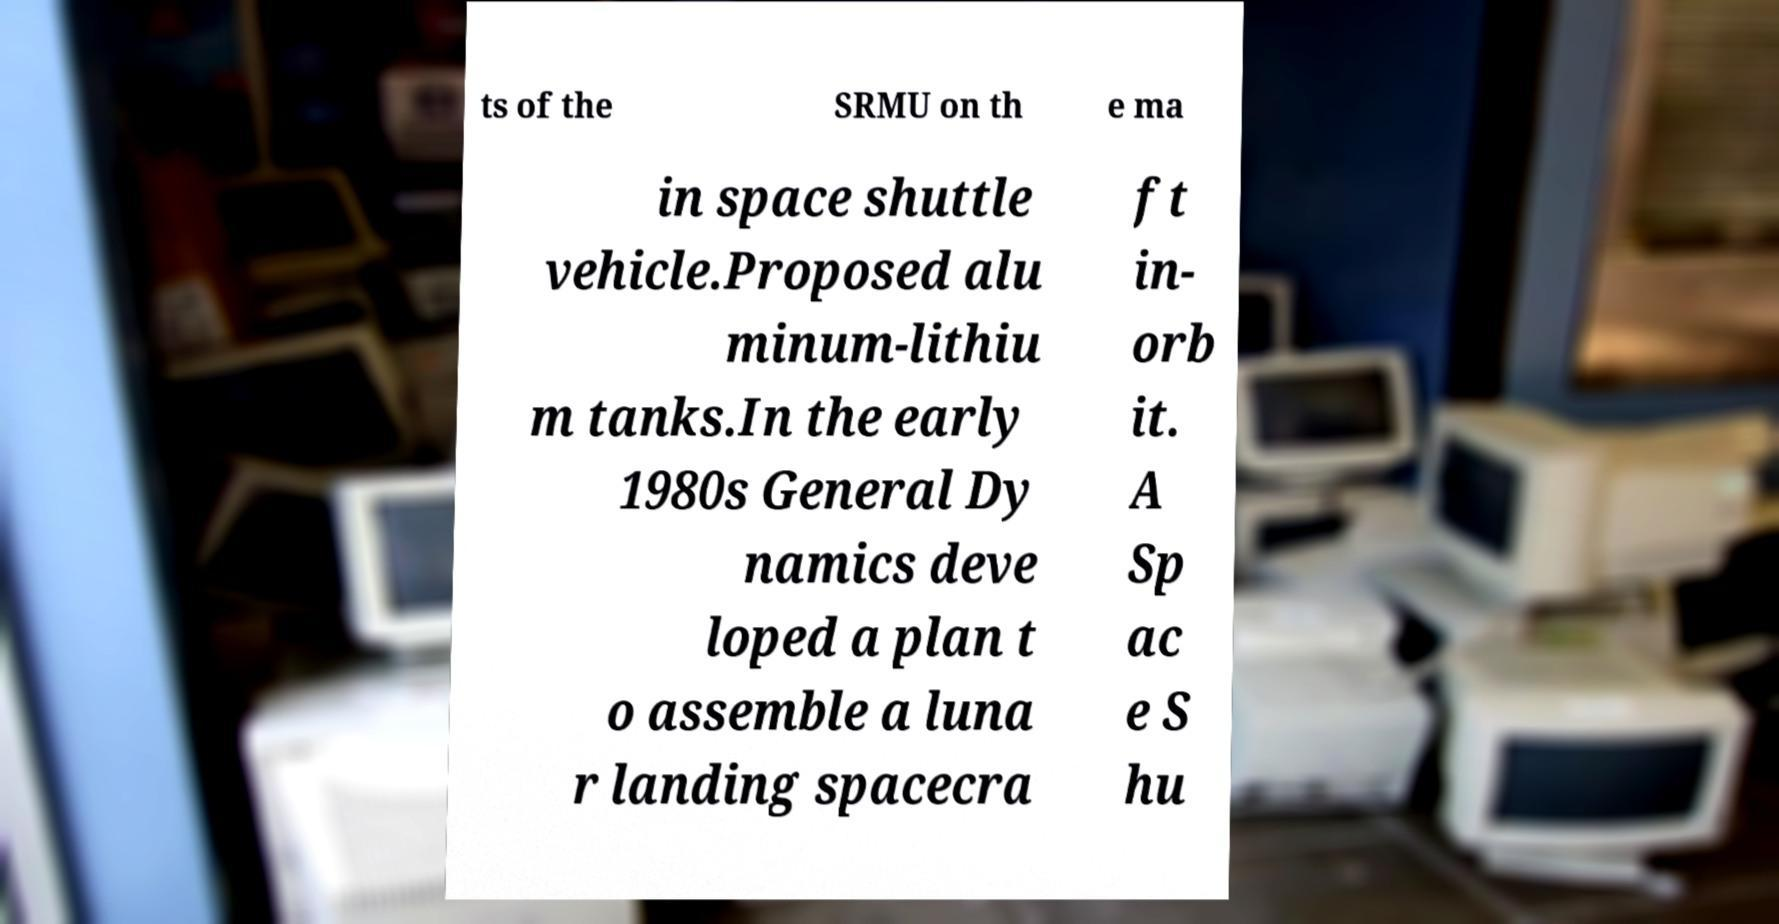Can you read and provide the text displayed in the image?This photo seems to have some interesting text. Can you extract and type it out for me? ts of the SRMU on th e ma in space shuttle vehicle.Proposed alu minum-lithiu m tanks.In the early 1980s General Dy namics deve loped a plan t o assemble a luna r landing spacecra ft in- orb it. A Sp ac e S hu 